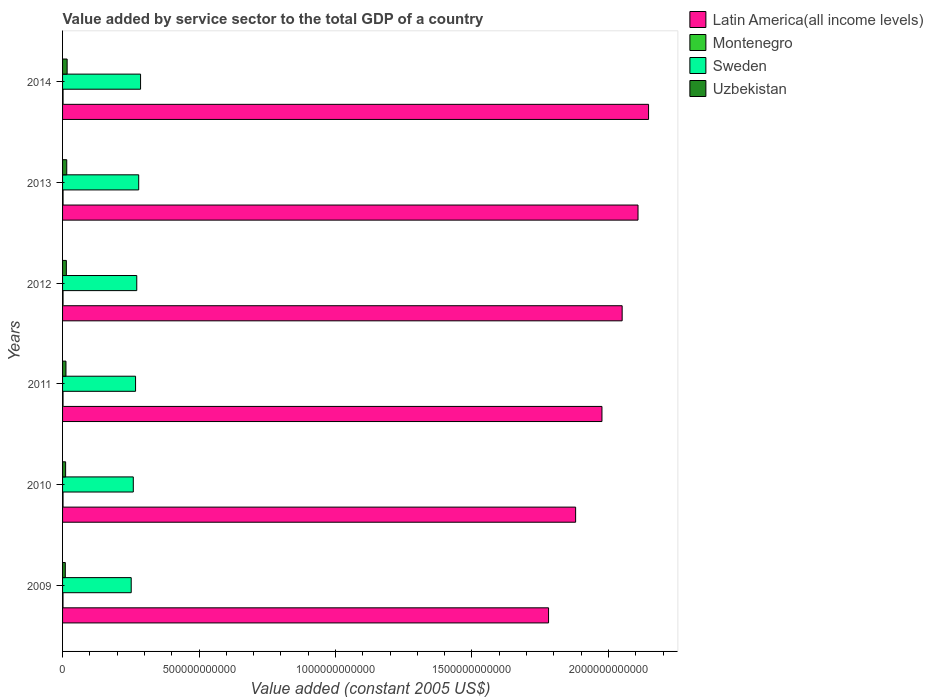Are the number of bars per tick equal to the number of legend labels?
Give a very brief answer. Yes. Are the number of bars on each tick of the Y-axis equal?
Keep it short and to the point. Yes. How many bars are there on the 2nd tick from the top?
Keep it short and to the point. 4. In how many cases, is the number of bars for a given year not equal to the number of legend labels?
Give a very brief answer. 0. What is the value added by service sector in Montenegro in 2011?
Give a very brief answer. 1.70e+09. Across all years, what is the maximum value added by service sector in Latin America(all income levels)?
Provide a succinct answer. 2.15e+12. Across all years, what is the minimum value added by service sector in Sweden?
Make the answer very short. 2.51e+11. In which year was the value added by service sector in Uzbekistan maximum?
Offer a terse response. 2014. What is the total value added by service sector in Latin America(all income levels) in the graph?
Ensure brevity in your answer.  1.19e+13. What is the difference between the value added by service sector in Latin America(all income levels) in 2009 and that in 2011?
Your answer should be compact. -1.96e+11. What is the difference between the value added by service sector in Latin America(all income levels) in 2013 and the value added by service sector in Uzbekistan in 2012?
Give a very brief answer. 2.09e+12. What is the average value added by service sector in Sweden per year?
Give a very brief answer. 2.69e+11. In the year 2012, what is the difference between the value added by service sector in Sweden and value added by service sector in Montenegro?
Your answer should be very brief. 2.70e+11. In how many years, is the value added by service sector in Latin America(all income levels) greater than 1500000000000 US$?
Your response must be concise. 6. What is the ratio of the value added by service sector in Uzbekistan in 2011 to that in 2014?
Provide a succinct answer. 0.75. Is the value added by service sector in Montenegro in 2012 less than that in 2013?
Offer a terse response. Yes. Is the difference between the value added by service sector in Sweden in 2011 and 2014 greater than the difference between the value added by service sector in Montenegro in 2011 and 2014?
Offer a terse response. No. What is the difference between the highest and the second highest value added by service sector in Latin America(all income levels)?
Your answer should be compact. 3.87e+1. What is the difference between the highest and the lowest value added by service sector in Montenegro?
Your answer should be compact. 1.94e+08. In how many years, is the value added by service sector in Uzbekistan greater than the average value added by service sector in Uzbekistan taken over all years?
Provide a short and direct response. 3. What does the 2nd bar from the top in 2013 represents?
Your answer should be compact. Sweden. What does the 2nd bar from the bottom in 2011 represents?
Keep it short and to the point. Montenegro. How many bars are there?
Ensure brevity in your answer.  24. What is the difference between two consecutive major ticks on the X-axis?
Your response must be concise. 5.00e+11. Are the values on the major ticks of X-axis written in scientific E-notation?
Provide a short and direct response. No. Does the graph contain any zero values?
Give a very brief answer. No. Does the graph contain grids?
Offer a very short reply. No. Where does the legend appear in the graph?
Provide a succinct answer. Top right. How are the legend labels stacked?
Your answer should be very brief. Vertical. What is the title of the graph?
Your answer should be very brief. Value added by service sector to the total GDP of a country. Does "Sint Maarten (Dutch part)" appear as one of the legend labels in the graph?
Offer a terse response. No. What is the label or title of the X-axis?
Give a very brief answer. Value added (constant 2005 US$). What is the label or title of the Y-axis?
Ensure brevity in your answer.  Years. What is the Value added (constant 2005 US$) in Latin America(all income levels) in 2009?
Offer a very short reply. 1.78e+12. What is the Value added (constant 2005 US$) in Montenegro in 2009?
Your answer should be compact. 1.62e+09. What is the Value added (constant 2005 US$) of Sweden in 2009?
Your answer should be very brief. 2.51e+11. What is the Value added (constant 2005 US$) in Uzbekistan in 2009?
Your response must be concise. 1.00e+1. What is the Value added (constant 2005 US$) of Latin America(all income levels) in 2010?
Offer a very short reply. 1.88e+12. What is the Value added (constant 2005 US$) of Montenegro in 2010?
Your answer should be compact. 1.68e+09. What is the Value added (constant 2005 US$) in Sweden in 2010?
Make the answer very short. 2.59e+11. What is the Value added (constant 2005 US$) in Uzbekistan in 2010?
Offer a terse response. 1.12e+1. What is the Value added (constant 2005 US$) in Latin America(all income levels) in 2011?
Offer a very short reply. 1.98e+12. What is the Value added (constant 2005 US$) in Montenegro in 2011?
Ensure brevity in your answer.  1.70e+09. What is the Value added (constant 2005 US$) of Sweden in 2011?
Offer a terse response. 2.67e+11. What is the Value added (constant 2005 US$) of Uzbekistan in 2011?
Ensure brevity in your answer.  1.25e+1. What is the Value added (constant 2005 US$) in Latin America(all income levels) in 2012?
Offer a terse response. 2.05e+12. What is the Value added (constant 2005 US$) in Montenegro in 2012?
Make the answer very short. 1.76e+09. What is the Value added (constant 2005 US$) of Sweden in 2012?
Provide a succinct answer. 2.72e+11. What is the Value added (constant 2005 US$) in Uzbekistan in 2012?
Make the answer very short. 1.39e+1. What is the Value added (constant 2005 US$) in Latin America(all income levels) in 2013?
Offer a very short reply. 2.11e+12. What is the Value added (constant 2005 US$) of Montenegro in 2013?
Provide a short and direct response. 1.80e+09. What is the Value added (constant 2005 US$) in Sweden in 2013?
Provide a succinct answer. 2.79e+11. What is the Value added (constant 2005 US$) of Uzbekistan in 2013?
Ensure brevity in your answer.  1.53e+1. What is the Value added (constant 2005 US$) in Latin America(all income levels) in 2014?
Provide a succinct answer. 2.15e+12. What is the Value added (constant 2005 US$) in Montenegro in 2014?
Your response must be concise. 1.81e+09. What is the Value added (constant 2005 US$) of Sweden in 2014?
Give a very brief answer. 2.86e+11. What is the Value added (constant 2005 US$) in Uzbekistan in 2014?
Make the answer very short. 1.68e+1. Across all years, what is the maximum Value added (constant 2005 US$) in Latin America(all income levels)?
Your answer should be very brief. 2.15e+12. Across all years, what is the maximum Value added (constant 2005 US$) in Montenegro?
Your response must be concise. 1.81e+09. Across all years, what is the maximum Value added (constant 2005 US$) in Sweden?
Keep it short and to the point. 2.86e+11. Across all years, what is the maximum Value added (constant 2005 US$) of Uzbekistan?
Your response must be concise. 1.68e+1. Across all years, what is the minimum Value added (constant 2005 US$) of Latin America(all income levels)?
Keep it short and to the point. 1.78e+12. Across all years, what is the minimum Value added (constant 2005 US$) in Montenegro?
Provide a succinct answer. 1.62e+09. Across all years, what is the minimum Value added (constant 2005 US$) in Sweden?
Your answer should be compact. 2.51e+11. Across all years, what is the minimum Value added (constant 2005 US$) in Uzbekistan?
Your response must be concise. 1.00e+1. What is the total Value added (constant 2005 US$) of Latin America(all income levels) in the graph?
Keep it short and to the point. 1.19e+13. What is the total Value added (constant 2005 US$) in Montenegro in the graph?
Offer a very short reply. 1.04e+1. What is the total Value added (constant 2005 US$) in Sweden in the graph?
Give a very brief answer. 1.61e+12. What is the total Value added (constant 2005 US$) in Uzbekistan in the graph?
Provide a short and direct response. 7.97e+1. What is the difference between the Value added (constant 2005 US$) of Latin America(all income levels) in 2009 and that in 2010?
Ensure brevity in your answer.  -9.91e+1. What is the difference between the Value added (constant 2005 US$) of Montenegro in 2009 and that in 2010?
Provide a succinct answer. -6.42e+07. What is the difference between the Value added (constant 2005 US$) in Sweden in 2009 and that in 2010?
Provide a succinct answer. -7.62e+09. What is the difference between the Value added (constant 2005 US$) of Uzbekistan in 2009 and that in 2010?
Your answer should be compact. -1.18e+09. What is the difference between the Value added (constant 2005 US$) in Latin America(all income levels) in 2009 and that in 2011?
Give a very brief answer. -1.96e+11. What is the difference between the Value added (constant 2005 US$) of Montenegro in 2009 and that in 2011?
Make the answer very short. -8.44e+07. What is the difference between the Value added (constant 2005 US$) in Sweden in 2009 and that in 2011?
Your answer should be compact. -1.60e+1. What is the difference between the Value added (constant 2005 US$) of Uzbekistan in 2009 and that in 2011?
Give a very brief answer. -2.45e+09. What is the difference between the Value added (constant 2005 US$) in Latin America(all income levels) in 2009 and that in 2012?
Provide a short and direct response. -2.70e+11. What is the difference between the Value added (constant 2005 US$) of Montenegro in 2009 and that in 2012?
Keep it short and to the point. -1.39e+08. What is the difference between the Value added (constant 2005 US$) of Sweden in 2009 and that in 2012?
Your answer should be compact. -2.04e+1. What is the difference between the Value added (constant 2005 US$) in Uzbekistan in 2009 and that in 2012?
Your answer should be compact. -3.89e+09. What is the difference between the Value added (constant 2005 US$) in Latin America(all income levels) in 2009 and that in 2013?
Give a very brief answer. -3.28e+11. What is the difference between the Value added (constant 2005 US$) in Montenegro in 2009 and that in 2013?
Ensure brevity in your answer.  -1.81e+08. What is the difference between the Value added (constant 2005 US$) of Sweden in 2009 and that in 2013?
Your response must be concise. -2.75e+1. What is the difference between the Value added (constant 2005 US$) of Uzbekistan in 2009 and that in 2013?
Make the answer very short. -5.27e+09. What is the difference between the Value added (constant 2005 US$) in Latin America(all income levels) in 2009 and that in 2014?
Offer a very short reply. -3.66e+11. What is the difference between the Value added (constant 2005 US$) in Montenegro in 2009 and that in 2014?
Make the answer very short. -1.94e+08. What is the difference between the Value added (constant 2005 US$) of Sweden in 2009 and that in 2014?
Your answer should be compact. -3.43e+1. What is the difference between the Value added (constant 2005 US$) of Uzbekistan in 2009 and that in 2014?
Your response must be concise. -6.73e+09. What is the difference between the Value added (constant 2005 US$) of Latin America(all income levels) in 2010 and that in 2011?
Give a very brief answer. -9.64e+1. What is the difference between the Value added (constant 2005 US$) of Montenegro in 2010 and that in 2011?
Your answer should be compact. -2.02e+07. What is the difference between the Value added (constant 2005 US$) in Sweden in 2010 and that in 2011?
Provide a succinct answer. -8.34e+09. What is the difference between the Value added (constant 2005 US$) in Uzbekistan in 2010 and that in 2011?
Your response must be concise. -1.27e+09. What is the difference between the Value added (constant 2005 US$) in Latin America(all income levels) in 2010 and that in 2012?
Offer a very short reply. -1.70e+11. What is the difference between the Value added (constant 2005 US$) in Montenegro in 2010 and that in 2012?
Provide a short and direct response. -7.44e+07. What is the difference between the Value added (constant 2005 US$) in Sweden in 2010 and that in 2012?
Provide a succinct answer. -1.27e+1. What is the difference between the Value added (constant 2005 US$) of Uzbekistan in 2010 and that in 2012?
Your answer should be compact. -2.71e+09. What is the difference between the Value added (constant 2005 US$) in Latin America(all income levels) in 2010 and that in 2013?
Make the answer very short. -2.29e+11. What is the difference between the Value added (constant 2005 US$) in Montenegro in 2010 and that in 2013?
Provide a succinct answer. -1.17e+08. What is the difference between the Value added (constant 2005 US$) of Sweden in 2010 and that in 2013?
Your answer should be very brief. -1.99e+1. What is the difference between the Value added (constant 2005 US$) of Uzbekistan in 2010 and that in 2013?
Provide a short and direct response. -4.09e+09. What is the difference between the Value added (constant 2005 US$) of Latin America(all income levels) in 2010 and that in 2014?
Give a very brief answer. -2.67e+11. What is the difference between the Value added (constant 2005 US$) in Montenegro in 2010 and that in 2014?
Keep it short and to the point. -1.30e+08. What is the difference between the Value added (constant 2005 US$) in Sweden in 2010 and that in 2014?
Provide a succinct answer. -2.66e+1. What is the difference between the Value added (constant 2005 US$) of Uzbekistan in 2010 and that in 2014?
Offer a terse response. -5.55e+09. What is the difference between the Value added (constant 2005 US$) of Latin America(all income levels) in 2011 and that in 2012?
Provide a succinct answer. -7.41e+1. What is the difference between the Value added (constant 2005 US$) of Montenegro in 2011 and that in 2012?
Offer a very short reply. -5.42e+07. What is the difference between the Value added (constant 2005 US$) in Sweden in 2011 and that in 2012?
Provide a succinct answer. -4.40e+09. What is the difference between the Value added (constant 2005 US$) in Uzbekistan in 2011 and that in 2012?
Offer a terse response. -1.43e+09. What is the difference between the Value added (constant 2005 US$) of Latin America(all income levels) in 2011 and that in 2013?
Provide a succinct answer. -1.32e+11. What is the difference between the Value added (constant 2005 US$) of Montenegro in 2011 and that in 2013?
Ensure brevity in your answer.  -9.65e+07. What is the difference between the Value added (constant 2005 US$) in Sweden in 2011 and that in 2013?
Your response must be concise. -1.15e+1. What is the difference between the Value added (constant 2005 US$) of Uzbekistan in 2011 and that in 2013?
Keep it short and to the point. -2.81e+09. What is the difference between the Value added (constant 2005 US$) in Latin America(all income levels) in 2011 and that in 2014?
Your answer should be very brief. -1.71e+11. What is the difference between the Value added (constant 2005 US$) of Montenegro in 2011 and that in 2014?
Your answer should be compact. -1.10e+08. What is the difference between the Value added (constant 2005 US$) in Sweden in 2011 and that in 2014?
Provide a succinct answer. -1.83e+1. What is the difference between the Value added (constant 2005 US$) in Uzbekistan in 2011 and that in 2014?
Ensure brevity in your answer.  -4.27e+09. What is the difference between the Value added (constant 2005 US$) of Latin America(all income levels) in 2012 and that in 2013?
Your answer should be compact. -5.81e+1. What is the difference between the Value added (constant 2005 US$) in Montenegro in 2012 and that in 2013?
Provide a succinct answer. -4.23e+07. What is the difference between the Value added (constant 2005 US$) in Sweden in 2012 and that in 2013?
Provide a short and direct response. -7.11e+09. What is the difference between the Value added (constant 2005 US$) of Uzbekistan in 2012 and that in 2013?
Provide a succinct answer. -1.38e+09. What is the difference between the Value added (constant 2005 US$) in Latin America(all income levels) in 2012 and that in 2014?
Give a very brief answer. -9.67e+1. What is the difference between the Value added (constant 2005 US$) in Montenegro in 2012 and that in 2014?
Your response must be concise. -5.59e+07. What is the difference between the Value added (constant 2005 US$) in Sweden in 2012 and that in 2014?
Give a very brief answer. -1.39e+1. What is the difference between the Value added (constant 2005 US$) of Uzbekistan in 2012 and that in 2014?
Provide a succinct answer. -2.84e+09. What is the difference between the Value added (constant 2005 US$) of Latin America(all income levels) in 2013 and that in 2014?
Give a very brief answer. -3.87e+1. What is the difference between the Value added (constant 2005 US$) of Montenegro in 2013 and that in 2014?
Keep it short and to the point. -1.36e+07. What is the difference between the Value added (constant 2005 US$) of Sweden in 2013 and that in 2014?
Your response must be concise. -6.79e+09. What is the difference between the Value added (constant 2005 US$) in Uzbekistan in 2013 and that in 2014?
Your response must be concise. -1.46e+09. What is the difference between the Value added (constant 2005 US$) in Latin America(all income levels) in 2009 and the Value added (constant 2005 US$) in Montenegro in 2010?
Provide a succinct answer. 1.78e+12. What is the difference between the Value added (constant 2005 US$) of Latin America(all income levels) in 2009 and the Value added (constant 2005 US$) of Sweden in 2010?
Provide a short and direct response. 1.52e+12. What is the difference between the Value added (constant 2005 US$) of Latin America(all income levels) in 2009 and the Value added (constant 2005 US$) of Uzbekistan in 2010?
Give a very brief answer. 1.77e+12. What is the difference between the Value added (constant 2005 US$) in Montenegro in 2009 and the Value added (constant 2005 US$) in Sweden in 2010?
Provide a succinct answer. -2.57e+11. What is the difference between the Value added (constant 2005 US$) of Montenegro in 2009 and the Value added (constant 2005 US$) of Uzbekistan in 2010?
Make the answer very short. -9.60e+09. What is the difference between the Value added (constant 2005 US$) of Sweden in 2009 and the Value added (constant 2005 US$) of Uzbekistan in 2010?
Your response must be concise. 2.40e+11. What is the difference between the Value added (constant 2005 US$) of Latin America(all income levels) in 2009 and the Value added (constant 2005 US$) of Montenegro in 2011?
Your answer should be compact. 1.78e+12. What is the difference between the Value added (constant 2005 US$) of Latin America(all income levels) in 2009 and the Value added (constant 2005 US$) of Sweden in 2011?
Give a very brief answer. 1.51e+12. What is the difference between the Value added (constant 2005 US$) of Latin America(all income levels) in 2009 and the Value added (constant 2005 US$) of Uzbekistan in 2011?
Offer a terse response. 1.77e+12. What is the difference between the Value added (constant 2005 US$) of Montenegro in 2009 and the Value added (constant 2005 US$) of Sweden in 2011?
Your response must be concise. -2.66e+11. What is the difference between the Value added (constant 2005 US$) of Montenegro in 2009 and the Value added (constant 2005 US$) of Uzbekistan in 2011?
Your answer should be very brief. -1.09e+1. What is the difference between the Value added (constant 2005 US$) in Sweden in 2009 and the Value added (constant 2005 US$) in Uzbekistan in 2011?
Make the answer very short. 2.39e+11. What is the difference between the Value added (constant 2005 US$) of Latin America(all income levels) in 2009 and the Value added (constant 2005 US$) of Montenegro in 2012?
Offer a terse response. 1.78e+12. What is the difference between the Value added (constant 2005 US$) of Latin America(all income levels) in 2009 and the Value added (constant 2005 US$) of Sweden in 2012?
Provide a short and direct response. 1.51e+12. What is the difference between the Value added (constant 2005 US$) in Latin America(all income levels) in 2009 and the Value added (constant 2005 US$) in Uzbekistan in 2012?
Ensure brevity in your answer.  1.77e+12. What is the difference between the Value added (constant 2005 US$) of Montenegro in 2009 and the Value added (constant 2005 US$) of Sweden in 2012?
Your response must be concise. -2.70e+11. What is the difference between the Value added (constant 2005 US$) of Montenegro in 2009 and the Value added (constant 2005 US$) of Uzbekistan in 2012?
Keep it short and to the point. -1.23e+1. What is the difference between the Value added (constant 2005 US$) of Sweden in 2009 and the Value added (constant 2005 US$) of Uzbekistan in 2012?
Your answer should be very brief. 2.38e+11. What is the difference between the Value added (constant 2005 US$) in Latin America(all income levels) in 2009 and the Value added (constant 2005 US$) in Montenegro in 2013?
Make the answer very short. 1.78e+12. What is the difference between the Value added (constant 2005 US$) of Latin America(all income levels) in 2009 and the Value added (constant 2005 US$) of Sweden in 2013?
Keep it short and to the point. 1.50e+12. What is the difference between the Value added (constant 2005 US$) of Latin America(all income levels) in 2009 and the Value added (constant 2005 US$) of Uzbekistan in 2013?
Ensure brevity in your answer.  1.77e+12. What is the difference between the Value added (constant 2005 US$) of Montenegro in 2009 and the Value added (constant 2005 US$) of Sweden in 2013?
Offer a terse response. -2.77e+11. What is the difference between the Value added (constant 2005 US$) of Montenegro in 2009 and the Value added (constant 2005 US$) of Uzbekistan in 2013?
Offer a very short reply. -1.37e+1. What is the difference between the Value added (constant 2005 US$) of Sweden in 2009 and the Value added (constant 2005 US$) of Uzbekistan in 2013?
Offer a very short reply. 2.36e+11. What is the difference between the Value added (constant 2005 US$) in Latin America(all income levels) in 2009 and the Value added (constant 2005 US$) in Montenegro in 2014?
Your answer should be compact. 1.78e+12. What is the difference between the Value added (constant 2005 US$) of Latin America(all income levels) in 2009 and the Value added (constant 2005 US$) of Sweden in 2014?
Provide a succinct answer. 1.49e+12. What is the difference between the Value added (constant 2005 US$) of Latin America(all income levels) in 2009 and the Value added (constant 2005 US$) of Uzbekistan in 2014?
Ensure brevity in your answer.  1.76e+12. What is the difference between the Value added (constant 2005 US$) of Montenegro in 2009 and the Value added (constant 2005 US$) of Sweden in 2014?
Your answer should be compact. -2.84e+11. What is the difference between the Value added (constant 2005 US$) of Montenegro in 2009 and the Value added (constant 2005 US$) of Uzbekistan in 2014?
Your response must be concise. -1.51e+1. What is the difference between the Value added (constant 2005 US$) in Sweden in 2009 and the Value added (constant 2005 US$) in Uzbekistan in 2014?
Keep it short and to the point. 2.35e+11. What is the difference between the Value added (constant 2005 US$) in Latin America(all income levels) in 2010 and the Value added (constant 2005 US$) in Montenegro in 2011?
Your response must be concise. 1.88e+12. What is the difference between the Value added (constant 2005 US$) of Latin America(all income levels) in 2010 and the Value added (constant 2005 US$) of Sweden in 2011?
Offer a very short reply. 1.61e+12. What is the difference between the Value added (constant 2005 US$) in Latin America(all income levels) in 2010 and the Value added (constant 2005 US$) in Uzbekistan in 2011?
Keep it short and to the point. 1.87e+12. What is the difference between the Value added (constant 2005 US$) in Montenegro in 2010 and the Value added (constant 2005 US$) in Sweden in 2011?
Give a very brief answer. -2.66e+11. What is the difference between the Value added (constant 2005 US$) of Montenegro in 2010 and the Value added (constant 2005 US$) of Uzbekistan in 2011?
Provide a succinct answer. -1.08e+1. What is the difference between the Value added (constant 2005 US$) of Sweden in 2010 and the Value added (constant 2005 US$) of Uzbekistan in 2011?
Offer a terse response. 2.47e+11. What is the difference between the Value added (constant 2005 US$) of Latin America(all income levels) in 2010 and the Value added (constant 2005 US$) of Montenegro in 2012?
Make the answer very short. 1.88e+12. What is the difference between the Value added (constant 2005 US$) in Latin America(all income levels) in 2010 and the Value added (constant 2005 US$) in Sweden in 2012?
Give a very brief answer. 1.61e+12. What is the difference between the Value added (constant 2005 US$) in Latin America(all income levels) in 2010 and the Value added (constant 2005 US$) in Uzbekistan in 2012?
Give a very brief answer. 1.87e+12. What is the difference between the Value added (constant 2005 US$) of Montenegro in 2010 and the Value added (constant 2005 US$) of Sweden in 2012?
Offer a terse response. -2.70e+11. What is the difference between the Value added (constant 2005 US$) of Montenegro in 2010 and the Value added (constant 2005 US$) of Uzbekistan in 2012?
Offer a terse response. -1.22e+1. What is the difference between the Value added (constant 2005 US$) in Sweden in 2010 and the Value added (constant 2005 US$) in Uzbekistan in 2012?
Offer a very short reply. 2.45e+11. What is the difference between the Value added (constant 2005 US$) of Latin America(all income levels) in 2010 and the Value added (constant 2005 US$) of Montenegro in 2013?
Make the answer very short. 1.88e+12. What is the difference between the Value added (constant 2005 US$) of Latin America(all income levels) in 2010 and the Value added (constant 2005 US$) of Sweden in 2013?
Your response must be concise. 1.60e+12. What is the difference between the Value added (constant 2005 US$) of Latin America(all income levels) in 2010 and the Value added (constant 2005 US$) of Uzbekistan in 2013?
Give a very brief answer. 1.86e+12. What is the difference between the Value added (constant 2005 US$) in Montenegro in 2010 and the Value added (constant 2005 US$) in Sweden in 2013?
Your answer should be compact. -2.77e+11. What is the difference between the Value added (constant 2005 US$) of Montenegro in 2010 and the Value added (constant 2005 US$) of Uzbekistan in 2013?
Offer a terse response. -1.36e+1. What is the difference between the Value added (constant 2005 US$) in Sweden in 2010 and the Value added (constant 2005 US$) in Uzbekistan in 2013?
Make the answer very short. 2.44e+11. What is the difference between the Value added (constant 2005 US$) of Latin America(all income levels) in 2010 and the Value added (constant 2005 US$) of Montenegro in 2014?
Provide a succinct answer. 1.88e+12. What is the difference between the Value added (constant 2005 US$) of Latin America(all income levels) in 2010 and the Value added (constant 2005 US$) of Sweden in 2014?
Your response must be concise. 1.59e+12. What is the difference between the Value added (constant 2005 US$) of Latin America(all income levels) in 2010 and the Value added (constant 2005 US$) of Uzbekistan in 2014?
Make the answer very short. 1.86e+12. What is the difference between the Value added (constant 2005 US$) in Montenegro in 2010 and the Value added (constant 2005 US$) in Sweden in 2014?
Give a very brief answer. -2.84e+11. What is the difference between the Value added (constant 2005 US$) of Montenegro in 2010 and the Value added (constant 2005 US$) of Uzbekistan in 2014?
Offer a terse response. -1.51e+1. What is the difference between the Value added (constant 2005 US$) in Sweden in 2010 and the Value added (constant 2005 US$) in Uzbekistan in 2014?
Your response must be concise. 2.42e+11. What is the difference between the Value added (constant 2005 US$) of Latin America(all income levels) in 2011 and the Value added (constant 2005 US$) of Montenegro in 2012?
Offer a very short reply. 1.97e+12. What is the difference between the Value added (constant 2005 US$) in Latin America(all income levels) in 2011 and the Value added (constant 2005 US$) in Sweden in 2012?
Provide a short and direct response. 1.70e+12. What is the difference between the Value added (constant 2005 US$) in Latin America(all income levels) in 2011 and the Value added (constant 2005 US$) in Uzbekistan in 2012?
Make the answer very short. 1.96e+12. What is the difference between the Value added (constant 2005 US$) of Montenegro in 2011 and the Value added (constant 2005 US$) of Sweden in 2012?
Ensure brevity in your answer.  -2.70e+11. What is the difference between the Value added (constant 2005 US$) in Montenegro in 2011 and the Value added (constant 2005 US$) in Uzbekistan in 2012?
Your response must be concise. -1.22e+1. What is the difference between the Value added (constant 2005 US$) of Sweden in 2011 and the Value added (constant 2005 US$) of Uzbekistan in 2012?
Your response must be concise. 2.54e+11. What is the difference between the Value added (constant 2005 US$) in Latin America(all income levels) in 2011 and the Value added (constant 2005 US$) in Montenegro in 2013?
Provide a succinct answer. 1.97e+12. What is the difference between the Value added (constant 2005 US$) in Latin America(all income levels) in 2011 and the Value added (constant 2005 US$) in Sweden in 2013?
Provide a succinct answer. 1.70e+12. What is the difference between the Value added (constant 2005 US$) in Latin America(all income levels) in 2011 and the Value added (constant 2005 US$) in Uzbekistan in 2013?
Your answer should be compact. 1.96e+12. What is the difference between the Value added (constant 2005 US$) in Montenegro in 2011 and the Value added (constant 2005 US$) in Sweden in 2013?
Provide a short and direct response. -2.77e+11. What is the difference between the Value added (constant 2005 US$) in Montenegro in 2011 and the Value added (constant 2005 US$) in Uzbekistan in 2013?
Keep it short and to the point. -1.36e+1. What is the difference between the Value added (constant 2005 US$) of Sweden in 2011 and the Value added (constant 2005 US$) of Uzbekistan in 2013?
Keep it short and to the point. 2.52e+11. What is the difference between the Value added (constant 2005 US$) in Latin America(all income levels) in 2011 and the Value added (constant 2005 US$) in Montenegro in 2014?
Provide a succinct answer. 1.97e+12. What is the difference between the Value added (constant 2005 US$) of Latin America(all income levels) in 2011 and the Value added (constant 2005 US$) of Sweden in 2014?
Your answer should be very brief. 1.69e+12. What is the difference between the Value added (constant 2005 US$) of Latin America(all income levels) in 2011 and the Value added (constant 2005 US$) of Uzbekistan in 2014?
Your answer should be compact. 1.96e+12. What is the difference between the Value added (constant 2005 US$) of Montenegro in 2011 and the Value added (constant 2005 US$) of Sweden in 2014?
Offer a terse response. -2.84e+11. What is the difference between the Value added (constant 2005 US$) of Montenegro in 2011 and the Value added (constant 2005 US$) of Uzbekistan in 2014?
Provide a short and direct response. -1.51e+1. What is the difference between the Value added (constant 2005 US$) of Sweden in 2011 and the Value added (constant 2005 US$) of Uzbekistan in 2014?
Provide a short and direct response. 2.51e+11. What is the difference between the Value added (constant 2005 US$) in Latin America(all income levels) in 2012 and the Value added (constant 2005 US$) in Montenegro in 2013?
Your response must be concise. 2.05e+12. What is the difference between the Value added (constant 2005 US$) of Latin America(all income levels) in 2012 and the Value added (constant 2005 US$) of Sweden in 2013?
Your answer should be very brief. 1.77e+12. What is the difference between the Value added (constant 2005 US$) of Latin America(all income levels) in 2012 and the Value added (constant 2005 US$) of Uzbekistan in 2013?
Give a very brief answer. 2.03e+12. What is the difference between the Value added (constant 2005 US$) of Montenegro in 2012 and the Value added (constant 2005 US$) of Sweden in 2013?
Your answer should be compact. -2.77e+11. What is the difference between the Value added (constant 2005 US$) in Montenegro in 2012 and the Value added (constant 2005 US$) in Uzbekistan in 2013?
Your answer should be compact. -1.35e+1. What is the difference between the Value added (constant 2005 US$) in Sweden in 2012 and the Value added (constant 2005 US$) in Uzbekistan in 2013?
Provide a succinct answer. 2.57e+11. What is the difference between the Value added (constant 2005 US$) in Latin America(all income levels) in 2012 and the Value added (constant 2005 US$) in Montenegro in 2014?
Make the answer very short. 2.05e+12. What is the difference between the Value added (constant 2005 US$) of Latin America(all income levels) in 2012 and the Value added (constant 2005 US$) of Sweden in 2014?
Offer a very short reply. 1.76e+12. What is the difference between the Value added (constant 2005 US$) in Latin America(all income levels) in 2012 and the Value added (constant 2005 US$) in Uzbekistan in 2014?
Ensure brevity in your answer.  2.03e+12. What is the difference between the Value added (constant 2005 US$) of Montenegro in 2012 and the Value added (constant 2005 US$) of Sweden in 2014?
Your answer should be very brief. -2.84e+11. What is the difference between the Value added (constant 2005 US$) of Montenegro in 2012 and the Value added (constant 2005 US$) of Uzbekistan in 2014?
Provide a succinct answer. -1.50e+1. What is the difference between the Value added (constant 2005 US$) in Sweden in 2012 and the Value added (constant 2005 US$) in Uzbekistan in 2014?
Your answer should be very brief. 2.55e+11. What is the difference between the Value added (constant 2005 US$) in Latin America(all income levels) in 2013 and the Value added (constant 2005 US$) in Montenegro in 2014?
Offer a very short reply. 2.11e+12. What is the difference between the Value added (constant 2005 US$) in Latin America(all income levels) in 2013 and the Value added (constant 2005 US$) in Sweden in 2014?
Your answer should be compact. 1.82e+12. What is the difference between the Value added (constant 2005 US$) in Latin America(all income levels) in 2013 and the Value added (constant 2005 US$) in Uzbekistan in 2014?
Provide a short and direct response. 2.09e+12. What is the difference between the Value added (constant 2005 US$) in Montenegro in 2013 and the Value added (constant 2005 US$) in Sweden in 2014?
Give a very brief answer. -2.84e+11. What is the difference between the Value added (constant 2005 US$) in Montenegro in 2013 and the Value added (constant 2005 US$) in Uzbekistan in 2014?
Your response must be concise. -1.50e+1. What is the difference between the Value added (constant 2005 US$) of Sweden in 2013 and the Value added (constant 2005 US$) of Uzbekistan in 2014?
Provide a short and direct response. 2.62e+11. What is the average Value added (constant 2005 US$) in Latin America(all income levels) per year?
Give a very brief answer. 1.99e+12. What is the average Value added (constant 2005 US$) in Montenegro per year?
Provide a short and direct response. 1.73e+09. What is the average Value added (constant 2005 US$) in Sweden per year?
Offer a terse response. 2.69e+11. What is the average Value added (constant 2005 US$) of Uzbekistan per year?
Provide a succinct answer. 1.33e+1. In the year 2009, what is the difference between the Value added (constant 2005 US$) in Latin America(all income levels) and Value added (constant 2005 US$) in Montenegro?
Your answer should be very brief. 1.78e+12. In the year 2009, what is the difference between the Value added (constant 2005 US$) of Latin America(all income levels) and Value added (constant 2005 US$) of Sweden?
Your answer should be compact. 1.53e+12. In the year 2009, what is the difference between the Value added (constant 2005 US$) in Latin America(all income levels) and Value added (constant 2005 US$) in Uzbekistan?
Make the answer very short. 1.77e+12. In the year 2009, what is the difference between the Value added (constant 2005 US$) in Montenegro and Value added (constant 2005 US$) in Sweden?
Provide a short and direct response. -2.50e+11. In the year 2009, what is the difference between the Value added (constant 2005 US$) in Montenegro and Value added (constant 2005 US$) in Uzbekistan?
Provide a succinct answer. -8.42e+09. In the year 2009, what is the difference between the Value added (constant 2005 US$) in Sweden and Value added (constant 2005 US$) in Uzbekistan?
Offer a very short reply. 2.41e+11. In the year 2010, what is the difference between the Value added (constant 2005 US$) of Latin America(all income levels) and Value added (constant 2005 US$) of Montenegro?
Provide a succinct answer. 1.88e+12. In the year 2010, what is the difference between the Value added (constant 2005 US$) of Latin America(all income levels) and Value added (constant 2005 US$) of Sweden?
Make the answer very short. 1.62e+12. In the year 2010, what is the difference between the Value added (constant 2005 US$) of Latin America(all income levels) and Value added (constant 2005 US$) of Uzbekistan?
Offer a very short reply. 1.87e+12. In the year 2010, what is the difference between the Value added (constant 2005 US$) of Montenegro and Value added (constant 2005 US$) of Sweden?
Offer a very short reply. -2.57e+11. In the year 2010, what is the difference between the Value added (constant 2005 US$) in Montenegro and Value added (constant 2005 US$) in Uzbekistan?
Make the answer very short. -9.53e+09. In the year 2010, what is the difference between the Value added (constant 2005 US$) in Sweden and Value added (constant 2005 US$) in Uzbekistan?
Offer a very short reply. 2.48e+11. In the year 2011, what is the difference between the Value added (constant 2005 US$) in Latin America(all income levels) and Value added (constant 2005 US$) in Montenegro?
Keep it short and to the point. 1.97e+12. In the year 2011, what is the difference between the Value added (constant 2005 US$) in Latin America(all income levels) and Value added (constant 2005 US$) in Sweden?
Keep it short and to the point. 1.71e+12. In the year 2011, what is the difference between the Value added (constant 2005 US$) of Latin America(all income levels) and Value added (constant 2005 US$) of Uzbekistan?
Offer a very short reply. 1.96e+12. In the year 2011, what is the difference between the Value added (constant 2005 US$) of Montenegro and Value added (constant 2005 US$) of Sweden?
Your response must be concise. -2.66e+11. In the year 2011, what is the difference between the Value added (constant 2005 US$) of Montenegro and Value added (constant 2005 US$) of Uzbekistan?
Offer a very short reply. -1.08e+1. In the year 2011, what is the difference between the Value added (constant 2005 US$) of Sweden and Value added (constant 2005 US$) of Uzbekistan?
Your answer should be very brief. 2.55e+11. In the year 2012, what is the difference between the Value added (constant 2005 US$) of Latin America(all income levels) and Value added (constant 2005 US$) of Montenegro?
Provide a succinct answer. 2.05e+12. In the year 2012, what is the difference between the Value added (constant 2005 US$) in Latin America(all income levels) and Value added (constant 2005 US$) in Sweden?
Your answer should be very brief. 1.78e+12. In the year 2012, what is the difference between the Value added (constant 2005 US$) of Latin America(all income levels) and Value added (constant 2005 US$) of Uzbekistan?
Ensure brevity in your answer.  2.04e+12. In the year 2012, what is the difference between the Value added (constant 2005 US$) of Montenegro and Value added (constant 2005 US$) of Sweden?
Your answer should be compact. -2.70e+11. In the year 2012, what is the difference between the Value added (constant 2005 US$) of Montenegro and Value added (constant 2005 US$) of Uzbekistan?
Provide a succinct answer. -1.22e+1. In the year 2012, what is the difference between the Value added (constant 2005 US$) of Sweden and Value added (constant 2005 US$) of Uzbekistan?
Provide a short and direct response. 2.58e+11. In the year 2013, what is the difference between the Value added (constant 2005 US$) in Latin America(all income levels) and Value added (constant 2005 US$) in Montenegro?
Provide a short and direct response. 2.11e+12. In the year 2013, what is the difference between the Value added (constant 2005 US$) of Latin America(all income levels) and Value added (constant 2005 US$) of Sweden?
Make the answer very short. 1.83e+12. In the year 2013, what is the difference between the Value added (constant 2005 US$) in Latin America(all income levels) and Value added (constant 2005 US$) in Uzbekistan?
Provide a succinct answer. 2.09e+12. In the year 2013, what is the difference between the Value added (constant 2005 US$) of Montenegro and Value added (constant 2005 US$) of Sweden?
Give a very brief answer. -2.77e+11. In the year 2013, what is the difference between the Value added (constant 2005 US$) of Montenegro and Value added (constant 2005 US$) of Uzbekistan?
Make the answer very short. -1.35e+1. In the year 2013, what is the difference between the Value added (constant 2005 US$) of Sweden and Value added (constant 2005 US$) of Uzbekistan?
Provide a succinct answer. 2.64e+11. In the year 2014, what is the difference between the Value added (constant 2005 US$) in Latin America(all income levels) and Value added (constant 2005 US$) in Montenegro?
Your response must be concise. 2.15e+12. In the year 2014, what is the difference between the Value added (constant 2005 US$) of Latin America(all income levels) and Value added (constant 2005 US$) of Sweden?
Offer a terse response. 1.86e+12. In the year 2014, what is the difference between the Value added (constant 2005 US$) in Latin America(all income levels) and Value added (constant 2005 US$) in Uzbekistan?
Make the answer very short. 2.13e+12. In the year 2014, what is the difference between the Value added (constant 2005 US$) in Montenegro and Value added (constant 2005 US$) in Sweden?
Give a very brief answer. -2.84e+11. In the year 2014, what is the difference between the Value added (constant 2005 US$) of Montenegro and Value added (constant 2005 US$) of Uzbekistan?
Make the answer very short. -1.50e+1. In the year 2014, what is the difference between the Value added (constant 2005 US$) of Sweden and Value added (constant 2005 US$) of Uzbekistan?
Provide a short and direct response. 2.69e+11. What is the ratio of the Value added (constant 2005 US$) of Latin America(all income levels) in 2009 to that in 2010?
Your answer should be very brief. 0.95. What is the ratio of the Value added (constant 2005 US$) in Montenegro in 2009 to that in 2010?
Offer a terse response. 0.96. What is the ratio of the Value added (constant 2005 US$) in Sweden in 2009 to that in 2010?
Offer a very short reply. 0.97. What is the ratio of the Value added (constant 2005 US$) in Uzbekistan in 2009 to that in 2010?
Your answer should be very brief. 0.89. What is the ratio of the Value added (constant 2005 US$) of Latin America(all income levels) in 2009 to that in 2011?
Your answer should be very brief. 0.9. What is the ratio of the Value added (constant 2005 US$) of Montenegro in 2009 to that in 2011?
Your answer should be very brief. 0.95. What is the ratio of the Value added (constant 2005 US$) of Sweden in 2009 to that in 2011?
Keep it short and to the point. 0.94. What is the ratio of the Value added (constant 2005 US$) of Uzbekistan in 2009 to that in 2011?
Make the answer very short. 0.8. What is the ratio of the Value added (constant 2005 US$) in Latin America(all income levels) in 2009 to that in 2012?
Offer a very short reply. 0.87. What is the ratio of the Value added (constant 2005 US$) in Montenegro in 2009 to that in 2012?
Offer a very short reply. 0.92. What is the ratio of the Value added (constant 2005 US$) in Sweden in 2009 to that in 2012?
Offer a very short reply. 0.93. What is the ratio of the Value added (constant 2005 US$) of Uzbekistan in 2009 to that in 2012?
Keep it short and to the point. 0.72. What is the ratio of the Value added (constant 2005 US$) in Latin America(all income levels) in 2009 to that in 2013?
Your answer should be compact. 0.84. What is the ratio of the Value added (constant 2005 US$) in Montenegro in 2009 to that in 2013?
Your response must be concise. 0.9. What is the ratio of the Value added (constant 2005 US$) of Sweden in 2009 to that in 2013?
Offer a terse response. 0.9. What is the ratio of the Value added (constant 2005 US$) of Uzbekistan in 2009 to that in 2013?
Offer a terse response. 0.66. What is the ratio of the Value added (constant 2005 US$) in Latin America(all income levels) in 2009 to that in 2014?
Ensure brevity in your answer.  0.83. What is the ratio of the Value added (constant 2005 US$) of Montenegro in 2009 to that in 2014?
Ensure brevity in your answer.  0.89. What is the ratio of the Value added (constant 2005 US$) of Sweden in 2009 to that in 2014?
Offer a very short reply. 0.88. What is the ratio of the Value added (constant 2005 US$) in Uzbekistan in 2009 to that in 2014?
Offer a terse response. 0.6. What is the ratio of the Value added (constant 2005 US$) in Latin America(all income levels) in 2010 to that in 2011?
Offer a very short reply. 0.95. What is the ratio of the Value added (constant 2005 US$) of Sweden in 2010 to that in 2011?
Make the answer very short. 0.97. What is the ratio of the Value added (constant 2005 US$) in Uzbekistan in 2010 to that in 2011?
Ensure brevity in your answer.  0.9. What is the ratio of the Value added (constant 2005 US$) in Latin America(all income levels) in 2010 to that in 2012?
Provide a short and direct response. 0.92. What is the ratio of the Value added (constant 2005 US$) in Montenegro in 2010 to that in 2012?
Your response must be concise. 0.96. What is the ratio of the Value added (constant 2005 US$) in Sweden in 2010 to that in 2012?
Your answer should be compact. 0.95. What is the ratio of the Value added (constant 2005 US$) of Uzbekistan in 2010 to that in 2012?
Give a very brief answer. 0.81. What is the ratio of the Value added (constant 2005 US$) in Latin America(all income levels) in 2010 to that in 2013?
Keep it short and to the point. 0.89. What is the ratio of the Value added (constant 2005 US$) of Montenegro in 2010 to that in 2013?
Ensure brevity in your answer.  0.94. What is the ratio of the Value added (constant 2005 US$) of Sweden in 2010 to that in 2013?
Your answer should be compact. 0.93. What is the ratio of the Value added (constant 2005 US$) of Uzbekistan in 2010 to that in 2013?
Offer a terse response. 0.73. What is the ratio of the Value added (constant 2005 US$) in Latin America(all income levels) in 2010 to that in 2014?
Offer a terse response. 0.88. What is the ratio of the Value added (constant 2005 US$) in Montenegro in 2010 to that in 2014?
Provide a succinct answer. 0.93. What is the ratio of the Value added (constant 2005 US$) of Sweden in 2010 to that in 2014?
Provide a succinct answer. 0.91. What is the ratio of the Value added (constant 2005 US$) of Uzbekistan in 2010 to that in 2014?
Provide a short and direct response. 0.67. What is the ratio of the Value added (constant 2005 US$) in Latin America(all income levels) in 2011 to that in 2012?
Your response must be concise. 0.96. What is the ratio of the Value added (constant 2005 US$) in Montenegro in 2011 to that in 2012?
Offer a terse response. 0.97. What is the ratio of the Value added (constant 2005 US$) of Sweden in 2011 to that in 2012?
Your answer should be very brief. 0.98. What is the ratio of the Value added (constant 2005 US$) in Uzbekistan in 2011 to that in 2012?
Make the answer very short. 0.9. What is the ratio of the Value added (constant 2005 US$) in Latin America(all income levels) in 2011 to that in 2013?
Your answer should be compact. 0.94. What is the ratio of the Value added (constant 2005 US$) of Montenegro in 2011 to that in 2013?
Make the answer very short. 0.95. What is the ratio of the Value added (constant 2005 US$) of Sweden in 2011 to that in 2013?
Offer a terse response. 0.96. What is the ratio of the Value added (constant 2005 US$) of Uzbekistan in 2011 to that in 2013?
Give a very brief answer. 0.82. What is the ratio of the Value added (constant 2005 US$) in Latin America(all income levels) in 2011 to that in 2014?
Offer a terse response. 0.92. What is the ratio of the Value added (constant 2005 US$) in Montenegro in 2011 to that in 2014?
Make the answer very short. 0.94. What is the ratio of the Value added (constant 2005 US$) in Sweden in 2011 to that in 2014?
Provide a succinct answer. 0.94. What is the ratio of the Value added (constant 2005 US$) in Uzbekistan in 2011 to that in 2014?
Ensure brevity in your answer.  0.74. What is the ratio of the Value added (constant 2005 US$) of Latin America(all income levels) in 2012 to that in 2013?
Keep it short and to the point. 0.97. What is the ratio of the Value added (constant 2005 US$) of Montenegro in 2012 to that in 2013?
Your answer should be compact. 0.98. What is the ratio of the Value added (constant 2005 US$) of Sweden in 2012 to that in 2013?
Ensure brevity in your answer.  0.97. What is the ratio of the Value added (constant 2005 US$) of Uzbekistan in 2012 to that in 2013?
Offer a terse response. 0.91. What is the ratio of the Value added (constant 2005 US$) in Latin America(all income levels) in 2012 to that in 2014?
Offer a very short reply. 0.95. What is the ratio of the Value added (constant 2005 US$) in Montenegro in 2012 to that in 2014?
Make the answer very short. 0.97. What is the ratio of the Value added (constant 2005 US$) in Sweden in 2012 to that in 2014?
Your response must be concise. 0.95. What is the ratio of the Value added (constant 2005 US$) of Uzbekistan in 2012 to that in 2014?
Offer a very short reply. 0.83. What is the ratio of the Value added (constant 2005 US$) in Latin America(all income levels) in 2013 to that in 2014?
Give a very brief answer. 0.98. What is the ratio of the Value added (constant 2005 US$) of Montenegro in 2013 to that in 2014?
Your response must be concise. 0.99. What is the ratio of the Value added (constant 2005 US$) in Sweden in 2013 to that in 2014?
Make the answer very short. 0.98. What is the ratio of the Value added (constant 2005 US$) of Uzbekistan in 2013 to that in 2014?
Provide a succinct answer. 0.91. What is the difference between the highest and the second highest Value added (constant 2005 US$) in Latin America(all income levels)?
Give a very brief answer. 3.87e+1. What is the difference between the highest and the second highest Value added (constant 2005 US$) in Montenegro?
Provide a short and direct response. 1.36e+07. What is the difference between the highest and the second highest Value added (constant 2005 US$) in Sweden?
Your answer should be very brief. 6.79e+09. What is the difference between the highest and the second highest Value added (constant 2005 US$) in Uzbekistan?
Offer a very short reply. 1.46e+09. What is the difference between the highest and the lowest Value added (constant 2005 US$) of Latin America(all income levels)?
Offer a terse response. 3.66e+11. What is the difference between the highest and the lowest Value added (constant 2005 US$) in Montenegro?
Offer a very short reply. 1.94e+08. What is the difference between the highest and the lowest Value added (constant 2005 US$) in Sweden?
Offer a very short reply. 3.43e+1. What is the difference between the highest and the lowest Value added (constant 2005 US$) of Uzbekistan?
Provide a short and direct response. 6.73e+09. 